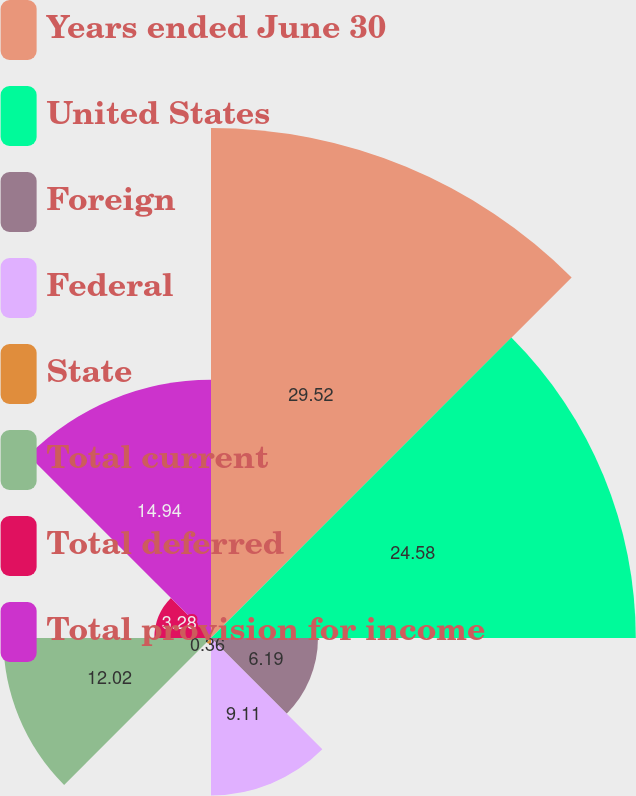Convert chart. <chart><loc_0><loc_0><loc_500><loc_500><pie_chart><fcel>Years ended June 30<fcel>United States<fcel>Foreign<fcel>Federal<fcel>State<fcel>Total current<fcel>Total deferred<fcel>Total provision for income<nl><fcel>29.51%<fcel>24.58%<fcel>6.19%<fcel>9.11%<fcel>0.36%<fcel>12.02%<fcel>3.28%<fcel>14.94%<nl></chart> 